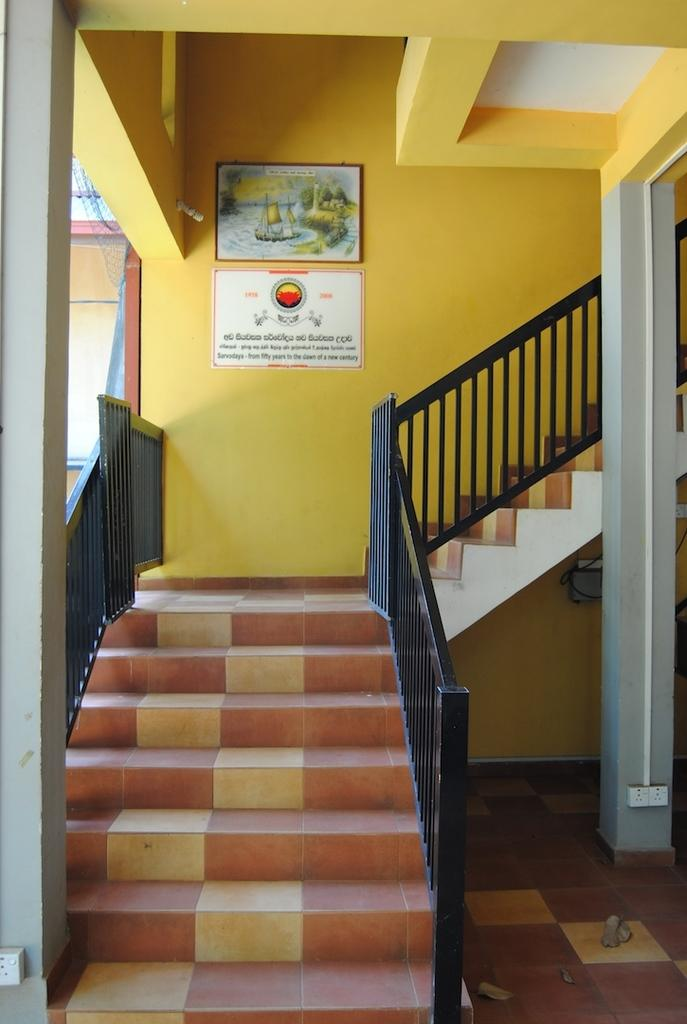What type of structure is present in the image? There are stairs in the image. Where do the stairs lead to? The stairs lead to the upper floor of a building. What can be seen on the wall near the stairs? There are boards on the wall in the image. How many knots are tied on the boards on the wall in the image? There is no mention of knots on the boards in the image. What is the plot of the story unfolding in the image? The image does not depict a story or plot; it is a static representation of stairs and boards on a wall. 